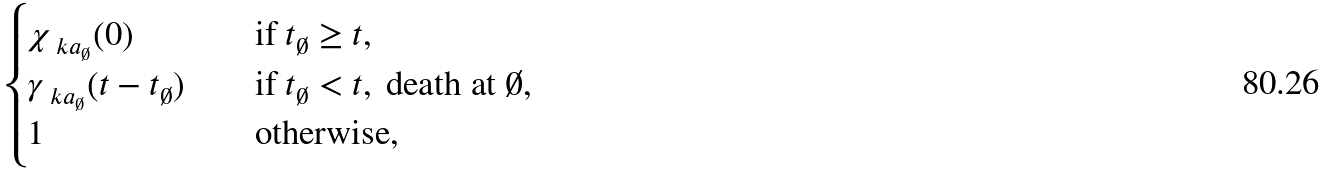Convert formula to latex. <formula><loc_0><loc_0><loc_500><loc_500>\begin{cases} \chi _ { \ k a _ { \emptyset } } ( 0 ) & \quad \text {if } t _ { \emptyset } \geq t , \\ \gamma _ { \ k a _ { \emptyset } } ( t - t _ { \emptyset } ) & \quad \text {if } t _ { \emptyset } < t , \text { death at } \emptyset , \\ 1 & \quad \text {otherwise,} \end{cases}</formula> 